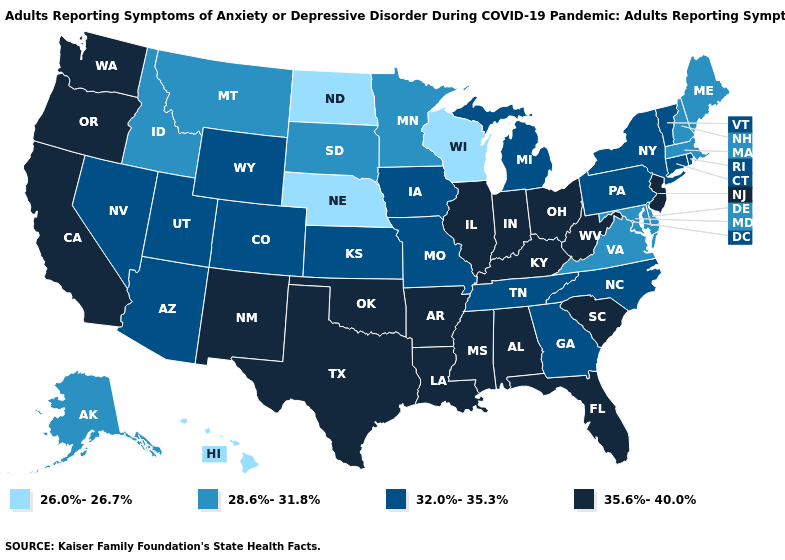What is the value of Wyoming?
Concise answer only. 32.0%-35.3%. Does Hawaii have the lowest value in the West?
Quick response, please. Yes. Among the states that border Nebraska , which have the lowest value?
Keep it brief. South Dakota. Does Colorado have the same value as Virginia?
Be succinct. No. What is the highest value in states that border Ohio?
Concise answer only. 35.6%-40.0%. What is the value of Illinois?
Give a very brief answer. 35.6%-40.0%. Name the states that have a value in the range 35.6%-40.0%?
Give a very brief answer. Alabama, Arkansas, California, Florida, Illinois, Indiana, Kentucky, Louisiana, Mississippi, New Jersey, New Mexico, Ohio, Oklahoma, Oregon, South Carolina, Texas, Washington, West Virginia. What is the lowest value in states that border New Hampshire?
Quick response, please. 28.6%-31.8%. Name the states that have a value in the range 35.6%-40.0%?
Be succinct. Alabama, Arkansas, California, Florida, Illinois, Indiana, Kentucky, Louisiana, Mississippi, New Jersey, New Mexico, Ohio, Oklahoma, Oregon, South Carolina, Texas, Washington, West Virginia. Name the states that have a value in the range 32.0%-35.3%?
Short answer required. Arizona, Colorado, Connecticut, Georgia, Iowa, Kansas, Michigan, Missouri, Nevada, New York, North Carolina, Pennsylvania, Rhode Island, Tennessee, Utah, Vermont, Wyoming. What is the value of Wisconsin?
Quick response, please. 26.0%-26.7%. Does Minnesota have the highest value in the MidWest?
Give a very brief answer. No. What is the highest value in states that border Kansas?
Concise answer only. 35.6%-40.0%. Name the states that have a value in the range 32.0%-35.3%?
Quick response, please. Arizona, Colorado, Connecticut, Georgia, Iowa, Kansas, Michigan, Missouri, Nevada, New York, North Carolina, Pennsylvania, Rhode Island, Tennessee, Utah, Vermont, Wyoming. What is the value of West Virginia?
Give a very brief answer. 35.6%-40.0%. 